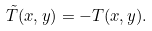<formula> <loc_0><loc_0><loc_500><loc_500>\tilde { T } ( x , y ) = - T ( x , y ) .</formula> 